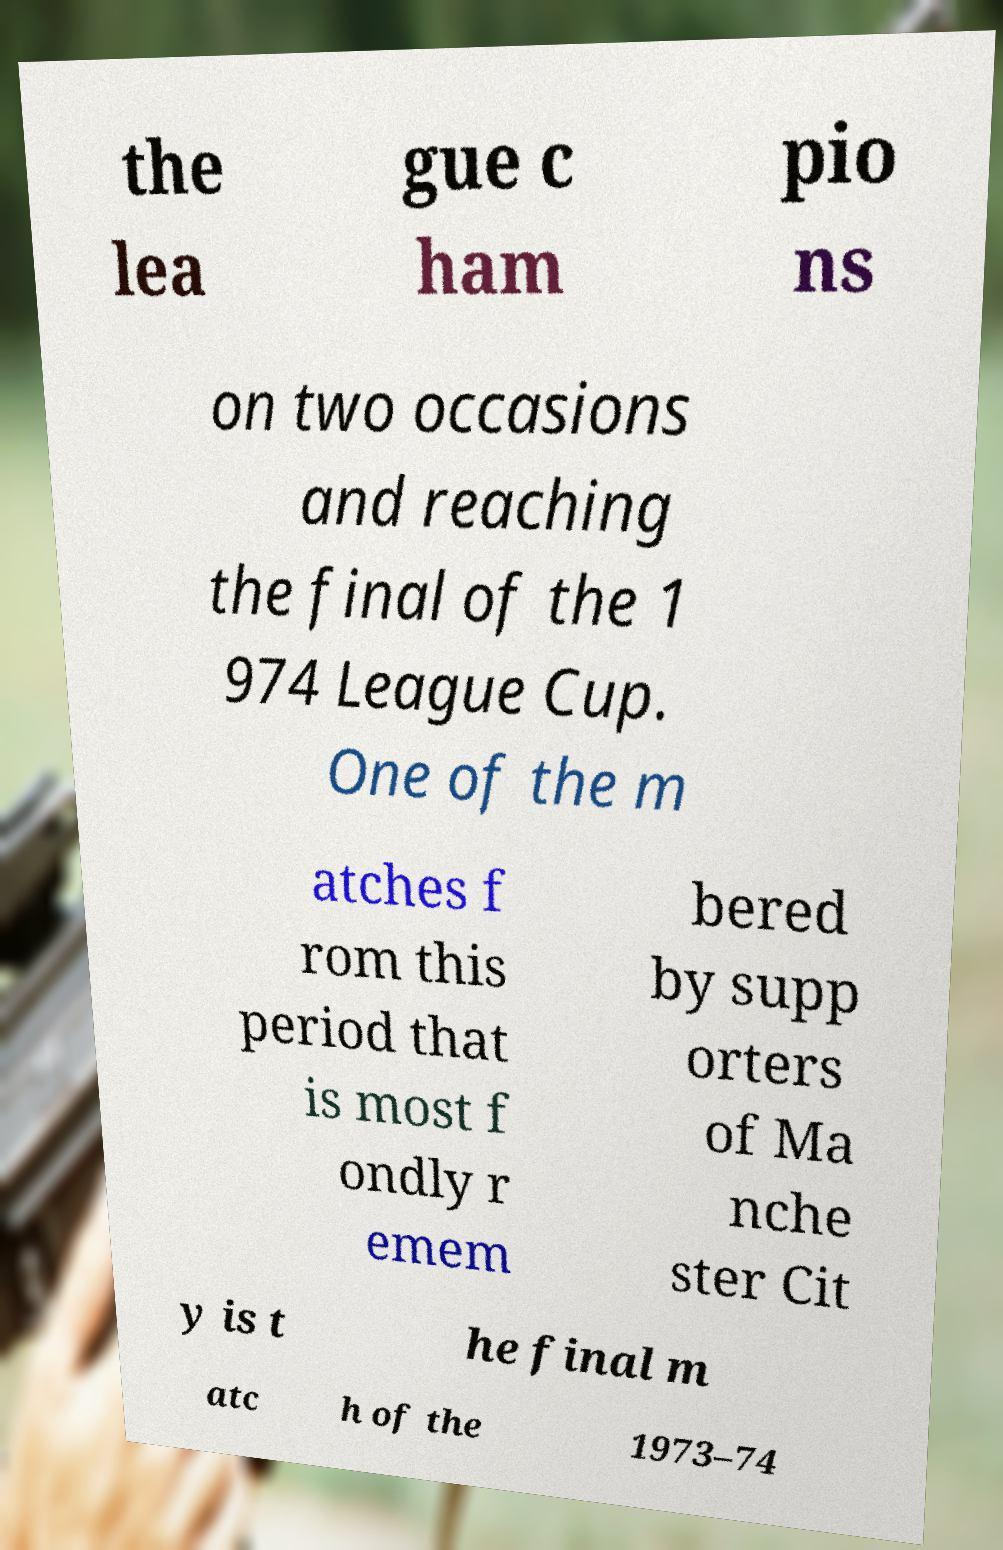Could you extract and type out the text from this image? the lea gue c ham pio ns on two occasions and reaching the final of the 1 974 League Cup. One of the m atches f rom this period that is most f ondly r emem bered by supp orters of Ma nche ster Cit y is t he final m atc h of the 1973–74 